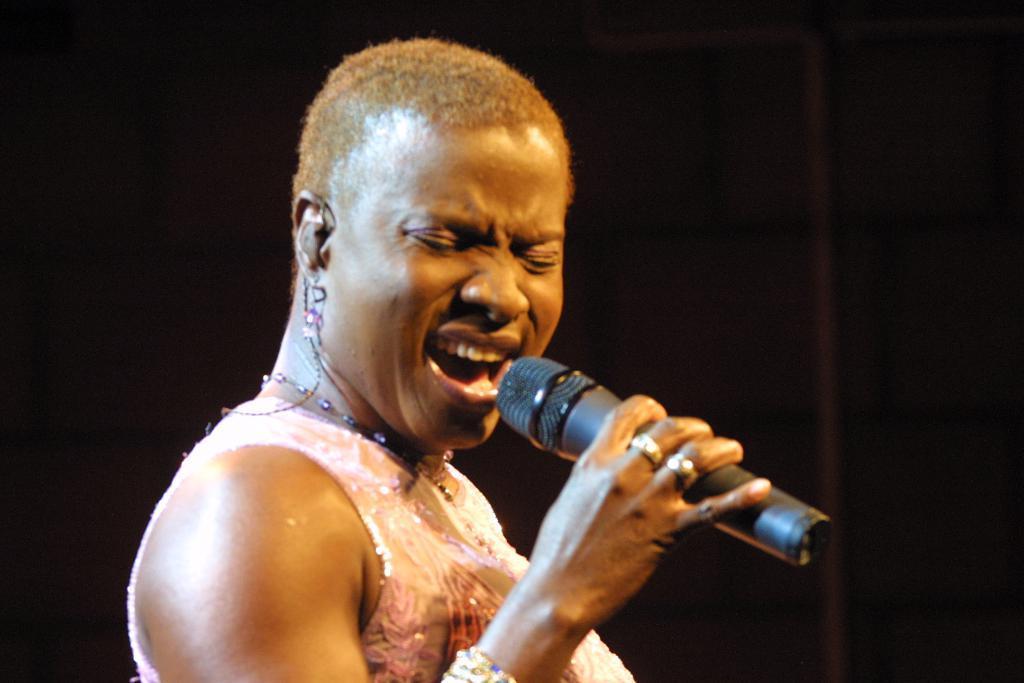Describe this image in one or two sentences. In this image I can see a woman is holding a mic 